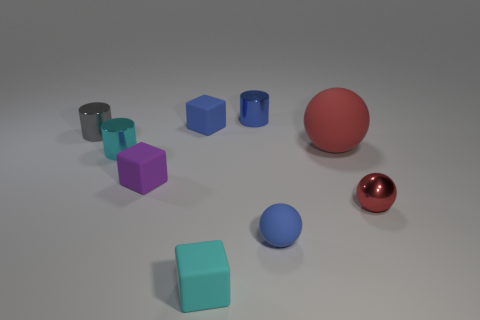Which object appears to be the largest, and can you guess its material? The largest object in the scene seems to be the red rubber ball, which stands out due to its vibrant hue and size relative to the other objects. Its material appears to be rubber based on its matte surface and the manner in which it interacts with the light in the scene, showing off a soft, diffuse reflection. 